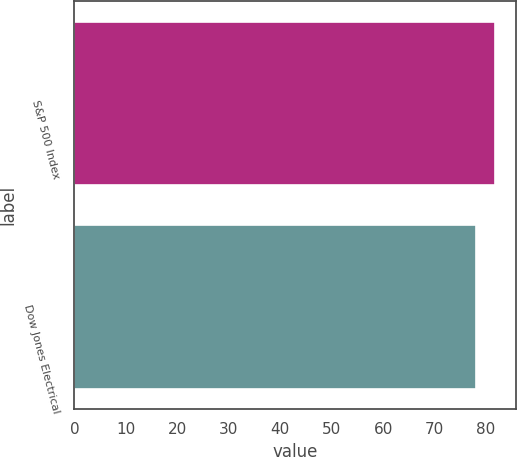Convert chart to OTSL. <chart><loc_0><loc_0><loc_500><loc_500><bar_chart><fcel>S&P 500 Index<fcel>Dow Jones Electrical<nl><fcel>81.76<fcel>78.08<nl></chart> 